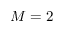Convert formula to latex. <formula><loc_0><loc_0><loc_500><loc_500>M = 2</formula> 